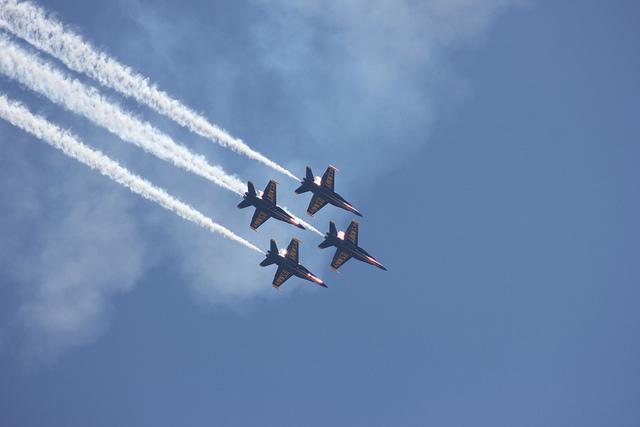How many planes are there?
Answer briefly. 4. How many streams of smoke are there?
Write a very short answer. 3. Is it cloudy?
Be succinct. No. How many airplanes are in flight?
Concise answer only. 4. Is this a military plane?
Be succinct. Yes. What type of planes are these?
Write a very short answer. Jets. What formation are the planes flying in?
Answer briefly. Diamond. 